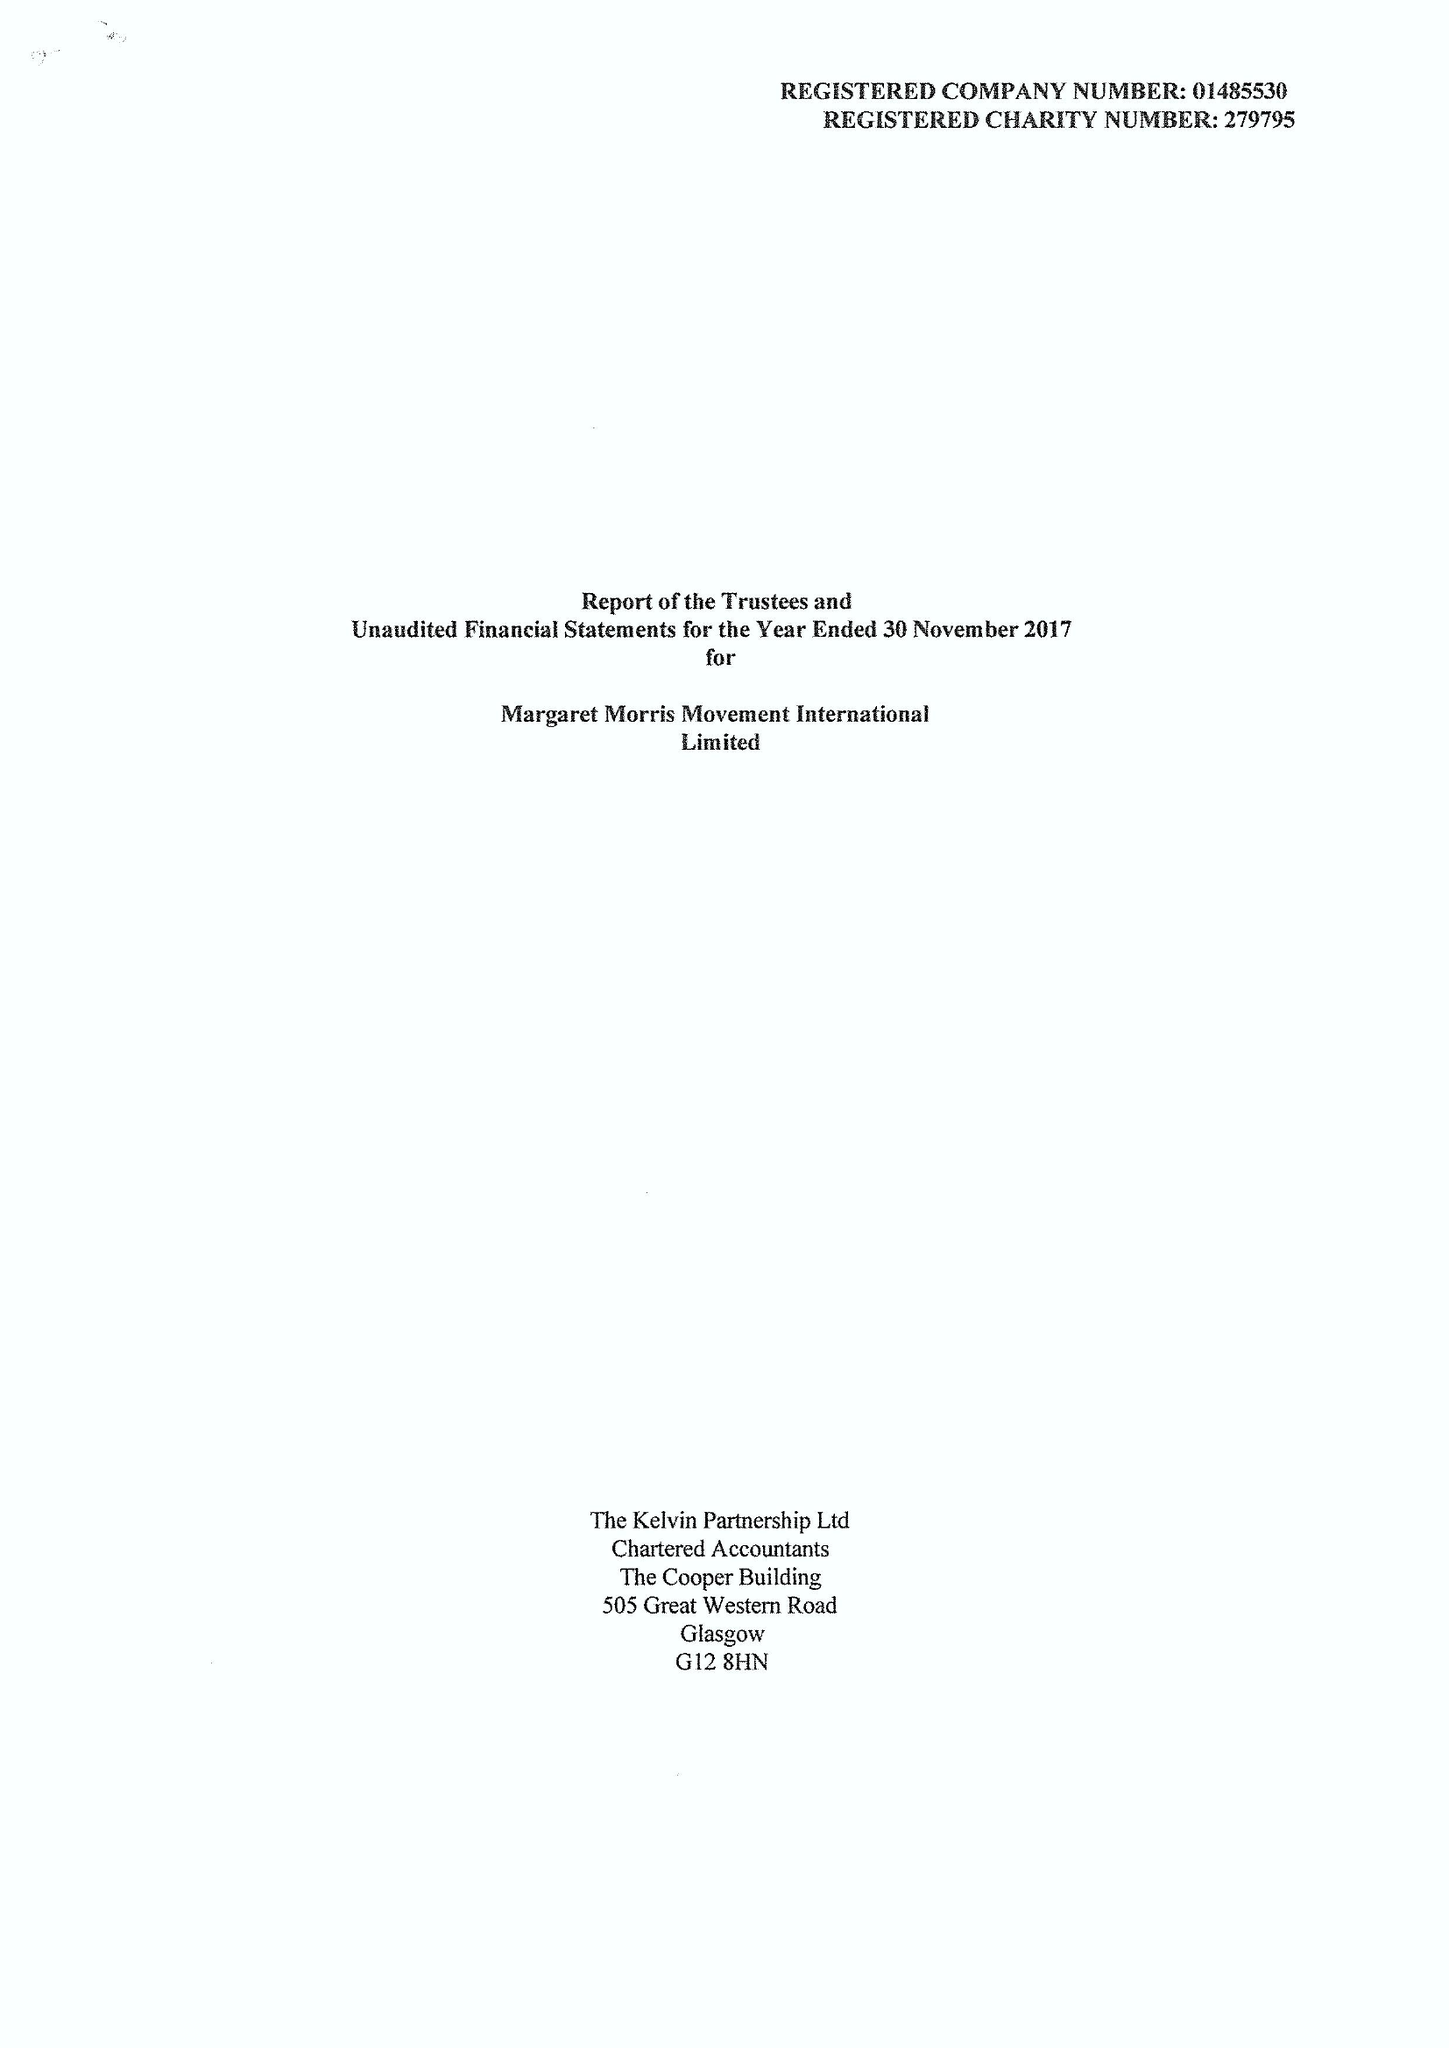What is the value for the charity_number?
Answer the question using a single word or phrase. 279795 